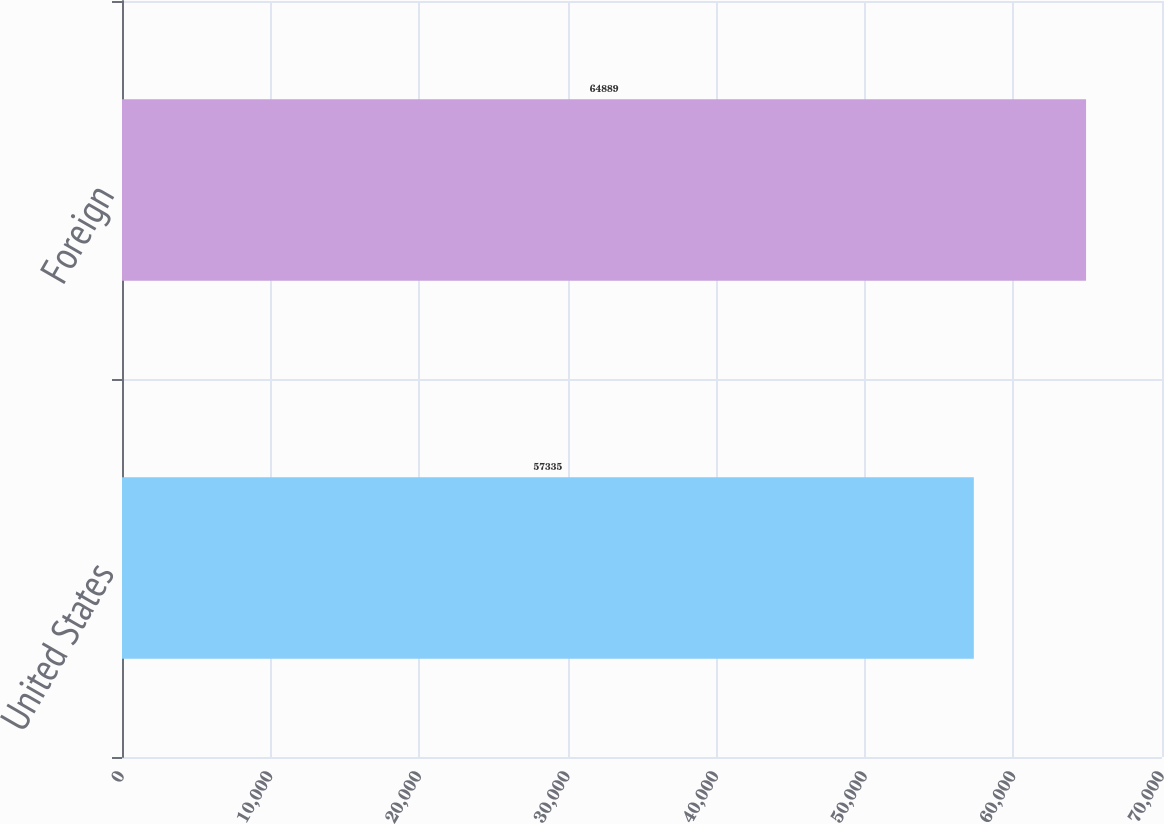Convert chart to OTSL. <chart><loc_0><loc_0><loc_500><loc_500><bar_chart><fcel>United States<fcel>Foreign<nl><fcel>57335<fcel>64889<nl></chart> 